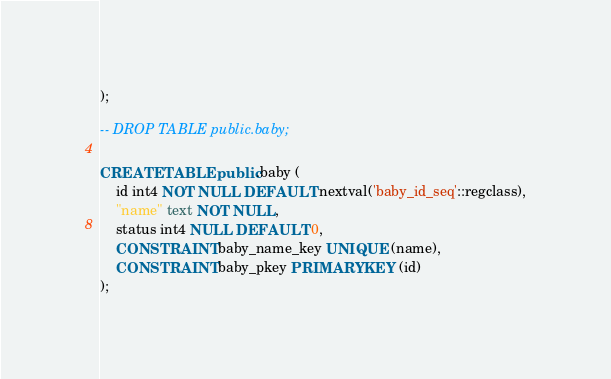Convert code to text. <code><loc_0><loc_0><loc_500><loc_500><_SQL_>);

-- DROP TABLE public.baby;

CREATE TABLE public.baby (
	id int4 NOT NULL DEFAULT nextval('baby_id_seq'::regclass),
	"name" text NOT NULL,
	status int4 NULL DEFAULT 0,
	CONSTRAINT baby_name_key UNIQUE (name),
	CONSTRAINT baby_pkey PRIMARY KEY (id)
);

</code> 